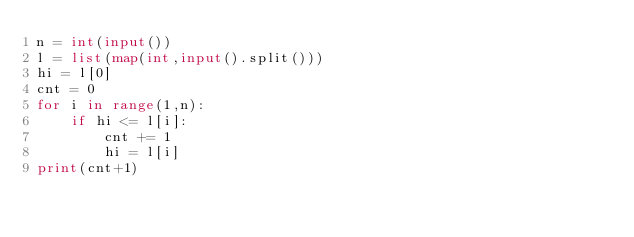<code> <loc_0><loc_0><loc_500><loc_500><_Python_>n = int(input())
l = list(map(int,input().split()))
hi = l[0]
cnt = 0
for i in range(1,n):
    if hi <= l[i]:
        cnt += 1
        hi = l[i]
print(cnt+1)
</code> 